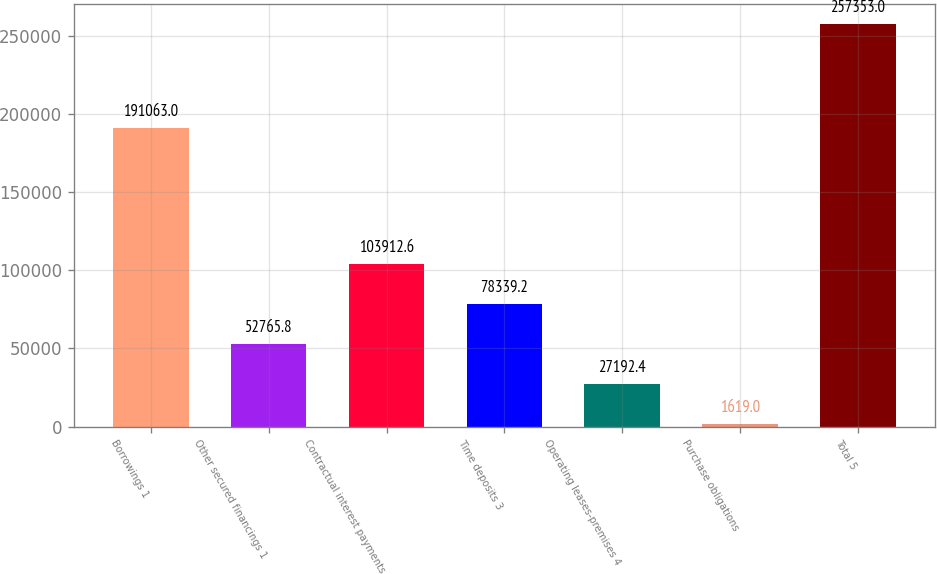Convert chart to OTSL. <chart><loc_0><loc_0><loc_500><loc_500><bar_chart><fcel>Borrowings 1<fcel>Other secured financings 1<fcel>Contractual interest payments<fcel>Time deposits 3<fcel>Operating leases-premises 4<fcel>Purchase obligations<fcel>Total 5<nl><fcel>191063<fcel>52765.8<fcel>103913<fcel>78339.2<fcel>27192.4<fcel>1619<fcel>257353<nl></chart> 